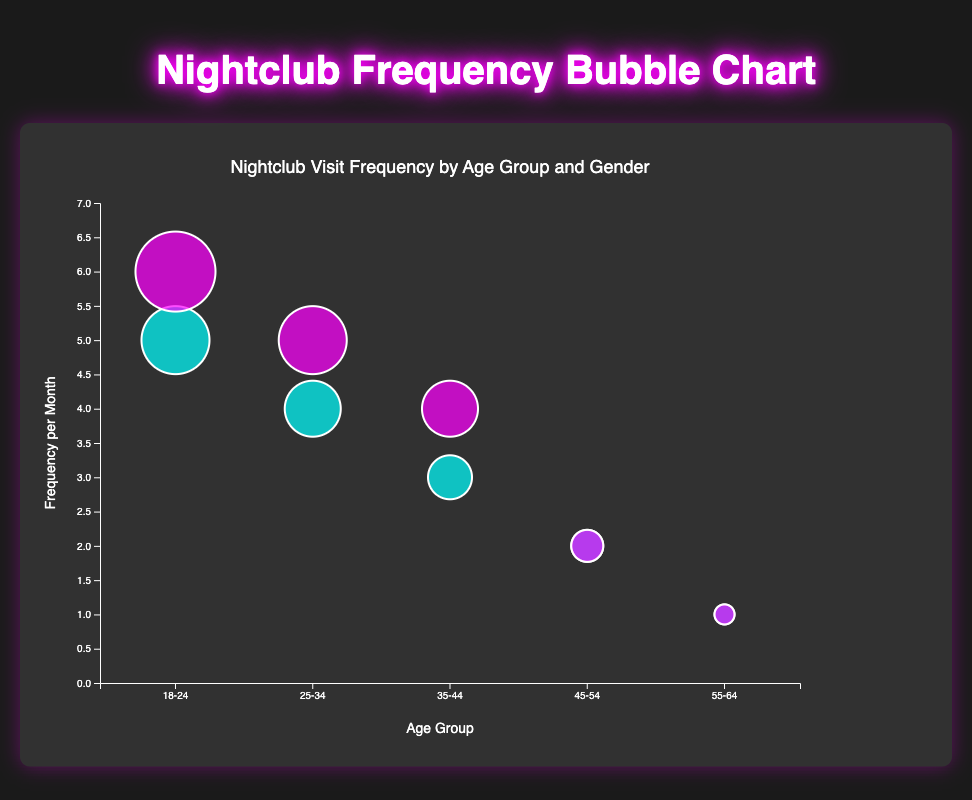What is the title of the chart? The chart's title is typically found at the top and gives an overview of what the chart is about. In this case, it states "Nightclub Visit Frequency by Age Group and Gender," indicating the main focus of the data visualization.
Answer: Nightclub Visit Frequency by Age Group and Gender Which age group has the highest frequency of nightclub visits per month? The chart shows the size of bubbles representing the frequency of nightclub visits per month. The largest bubble that reaches the highest position on the y-axis (indicating the highest frequency) is within the "18-24" age group for females, visiting Omnia 6 times per month.
Answer: 18-24 (Female, Omnia, 6 times) How many nightclubs are depicted in the chart? Each data point on the chart represents a distinct nightclub. By counting the bubbles, we can determine that there are a total of 10 different nightclubs mentioned: Hakkasan, Omnia, Marquee, E11EVEN, Zouk, Pacha, LIV, XS, Ministry of Sound, and Fabric.
Answer: 10 Which gender visits nightclubs more frequently in the "25-34" age group? Comparing the size of bubbles within the "25-34" age group, we find that the bubble representing "Female" visits E11EVEN 5 times per month, while the bubble for "Male" visits Marquee 4 times per month. Females in this age group visit nightclubs more frequently.
Answer: Female What is the combined total of nightclub visits per month for the "45-54" age group? Sum the frequency of visits for both genders in the "45-54" age group: 2 visits for males at LIV and 2 visits for females at XS. Therefore, the combined total is 2 + 2 = 4 visits per month.
Answer: 4 Which nightclub has the highest number of visits per month by females across all age groups? By examining bubbles representing female visits across all age groups, we identify the highest bubble for females visiting Omnia in the "18-24" age group with a frequency of 6 visits per month.
Answer: Omnia Which age group shows an equal frequency of nightclub visits for both genders? Looking at bubbles within age groups where the frequencies displayed on the y-axis are the same, the "45-54" age group shows equal frequency: males visit LIV twice per month, and females visit XS twice per month.
Answer: 45-54 What is the difference in nightclub visit frequency between males and females in the "35-44" age group? Calculate the difference in visits for the "35-44" age group: males visit Zouk 3 times per month, and females visit Pacha 4 times per month. The difference is 4 - 3 = 1 visit.
Answer: 1 What is the average nightclub visit frequency for the "55-64" age group? Calculate the mean of the frequencies for the "55-64" age group: males visit Ministry of Sound once per month, and females visit Fabric once per month. The average is (1 + 1) / 2 = 1 visit per month.
Answer: 1 Which gender has the largest bubble in the "18-24" age group, and which nightclub does it represent? Observing the "18-24" age group, the largest bubble (indicating the highest frequency) for females with 6 visits per month at Omnia is depicted. This bubble is larger and higher on the y-axis than the corresponding male bubble.
Answer: Female, Omnia 